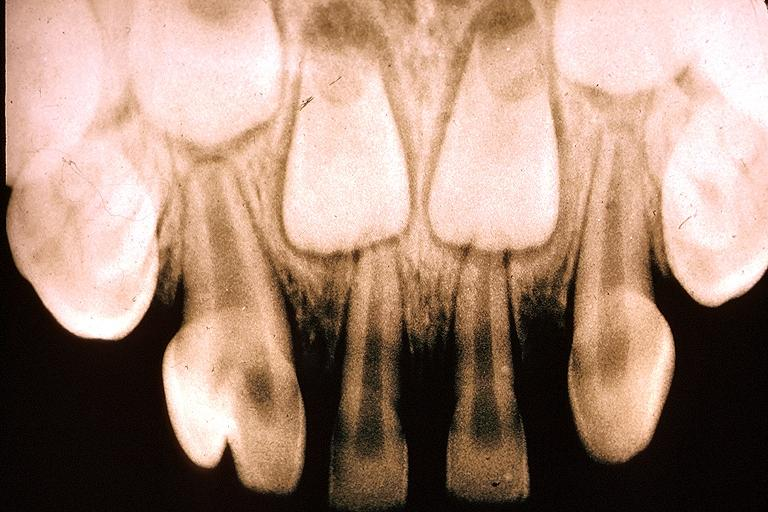where is this?
Answer the question using a single word or phrase. Oral 